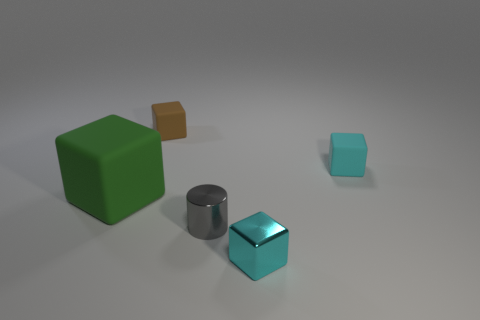Subtract 1 blocks. How many blocks are left? 3 Add 1 cyan matte objects. How many objects exist? 6 Subtract all cylinders. How many objects are left? 4 Subtract 1 gray cylinders. How many objects are left? 4 Subtract all green blocks. Subtract all tiny metal things. How many objects are left? 2 Add 3 small rubber things. How many small rubber things are left? 5 Add 1 green rubber things. How many green rubber things exist? 2 